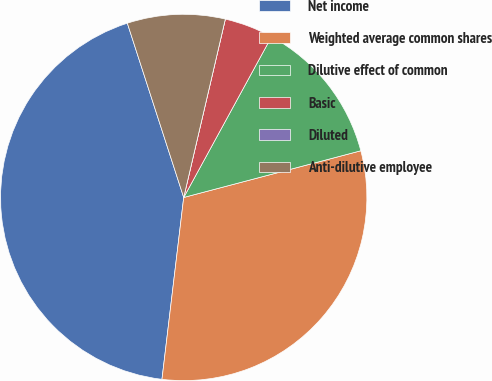Convert chart to OTSL. <chart><loc_0><loc_0><loc_500><loc_500><pie_chart><fcel>Net income<fcel>Weighted average common shares<fcel>Dilutive effect of common<fcel>Basic<fcel>Diluted<fcel>Anti-dilutive employee<nl><fcel>43.13%<fcel>31.0%<fcel>12.94%<fcel>4.31%<fcel>0.0%<fcel>8.63%<nl></chart> 